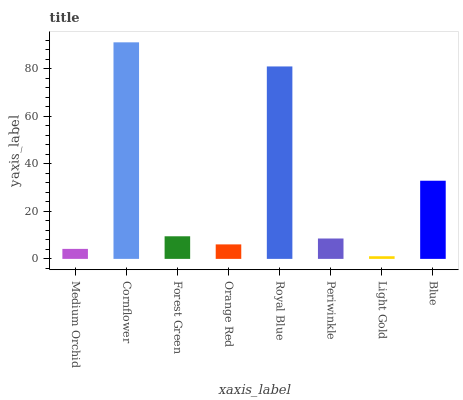Is Light Gold the minimum?
Answer yes or no. Yes. Is Cornflower the maximum?
Answer yes or no. Yes. Is Forest Green the minimum?
Answer yes or no. No. Is Forest Green the maximum?
Answer yes or no. No. Is Cornflower greater than Forest Green?
Answer yes or no. Yes. Is Forest Green less than Cornflower?
Answer yes or no. Yes. Is Forest Green greater than Cornflower?
Answer yes or no. No. Is Cornflower less than Forest Green?
Answer yes or no. No. Is Forest Green the high median?
Answer yes or no. Yes. Is Periwinkle the low median?
Answer yes or no. Yes. Is Cornflower the high median?
Answer yes or no. No. Is Blue the low median?
Answer yes or no. No. 